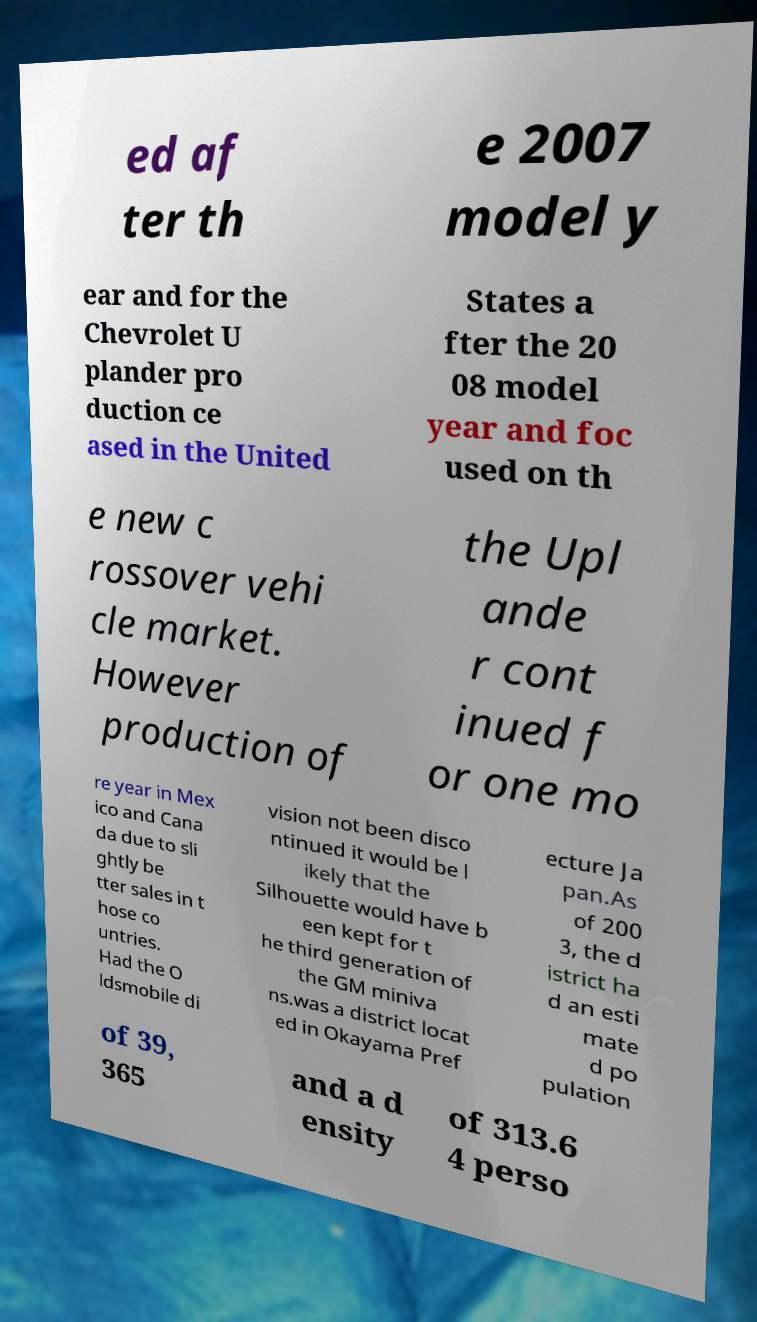Can you read and provide the text displayed in the image?This photo seems to have some interesting text. Can you extract and type it out for me? ed af ter th e 2007 model y ear and for the Chevrolet U plander pro duction ce ased in the United States a fter the 20 08 model year and foc used on th e new c rossover vehi cle market. However production of the Upl ande r cont inued f or one mo re year in Mex ico and Cana da due to sli ghtly be tter sales in t hose co untries. Had the O ldsmobile di vision not been disco ntinued it would be l ikely that the Silhouette would have b een kept for t he third generation of the GM miniva ns.was a district locat ed in Okayama Pref ecture Ja pan.As of 200 3, the d istrict ha d an esti mate d po pulation of 39, 365 and a d ensity of 313.6 4 perso 